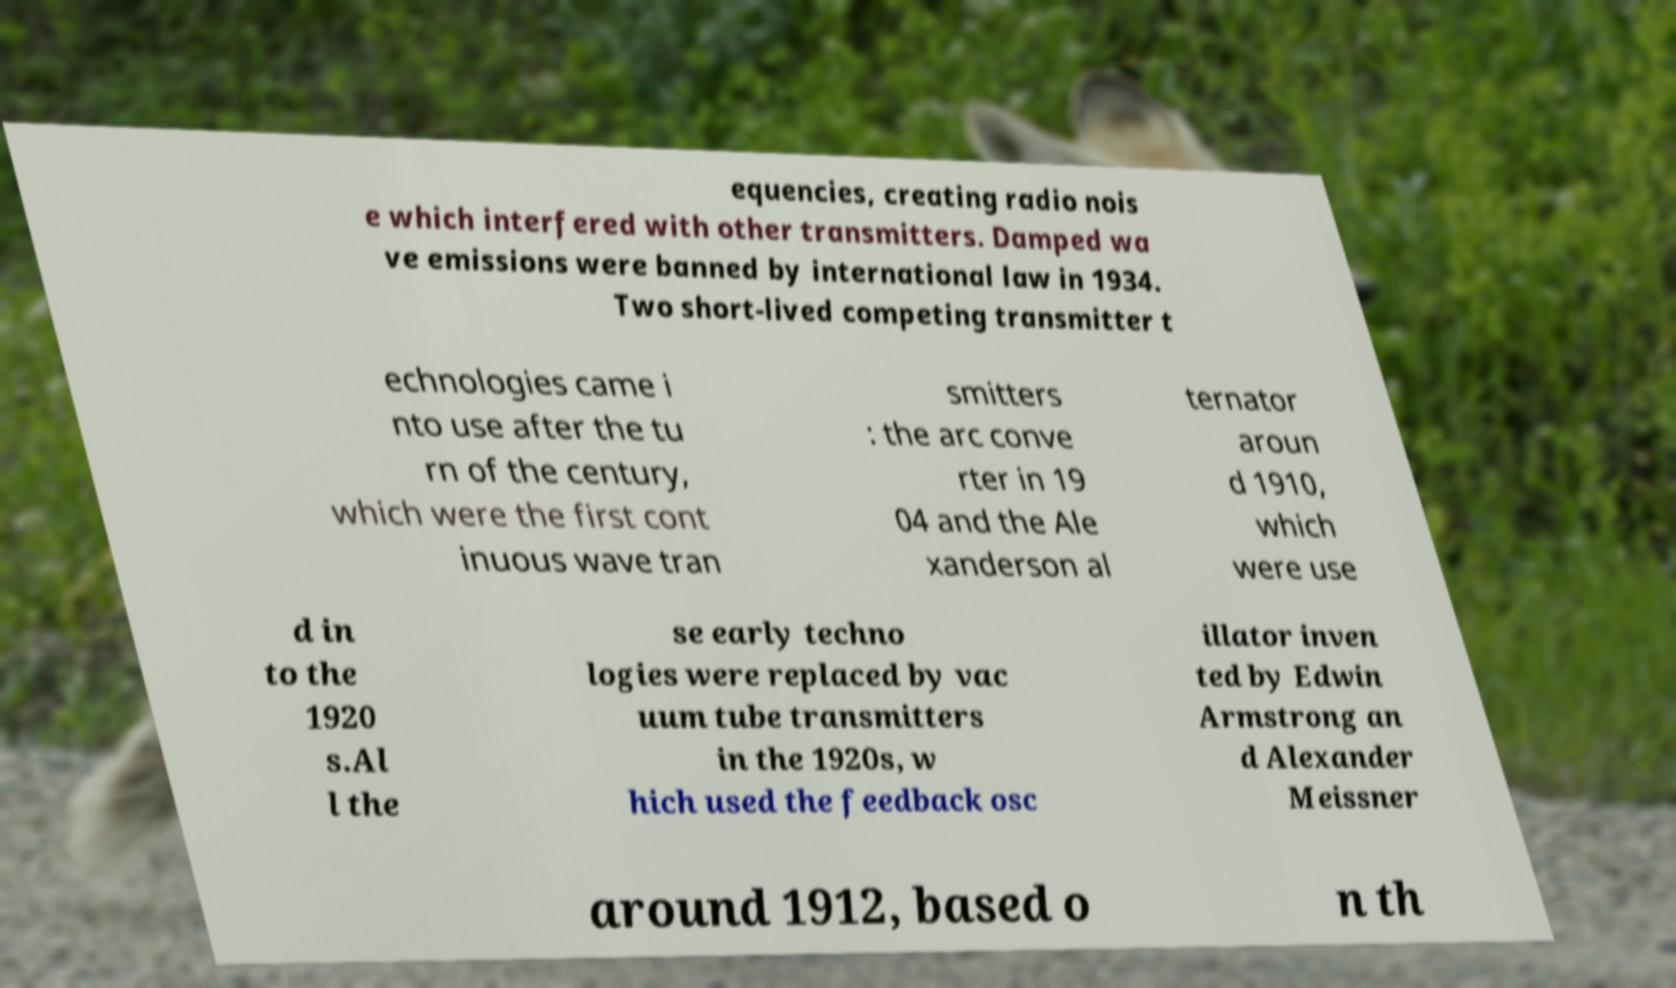What messages or text are displayed in this image? I need them in a readable, typed format. equencies, creating radio nois e which interfered with other transmitters. Damped wa ve emissions were banned by international law in 1934. Two short-lived competing transmitter t echnologies came i nto use after the tu rn of the century, which were the first cont inuous wave tran smitters : the arc conve rter in 19 04 and the Ale xanderson al ternator aroun d 1910, which were use d in to the 1920 s.Al l the se early techno logies were replaced by vac uum tube transmitters in the 1920s, w hich used the feedback osc illator inven ted by Edwin Armstrong an d Alexander Meissner around 1912, based o n th 